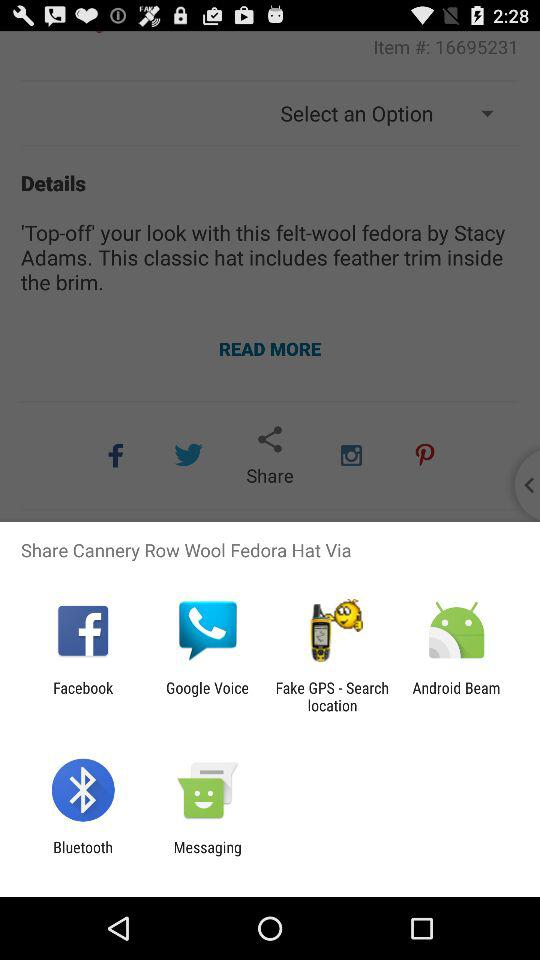What applications can be used to share the Cannery Row Wool Fedora Hat? The applications that can be used to share are "Facebook", "Google Voice", "Fake GPS - Search location", "Android Beam", "Bluetooth" and "Messaging". 